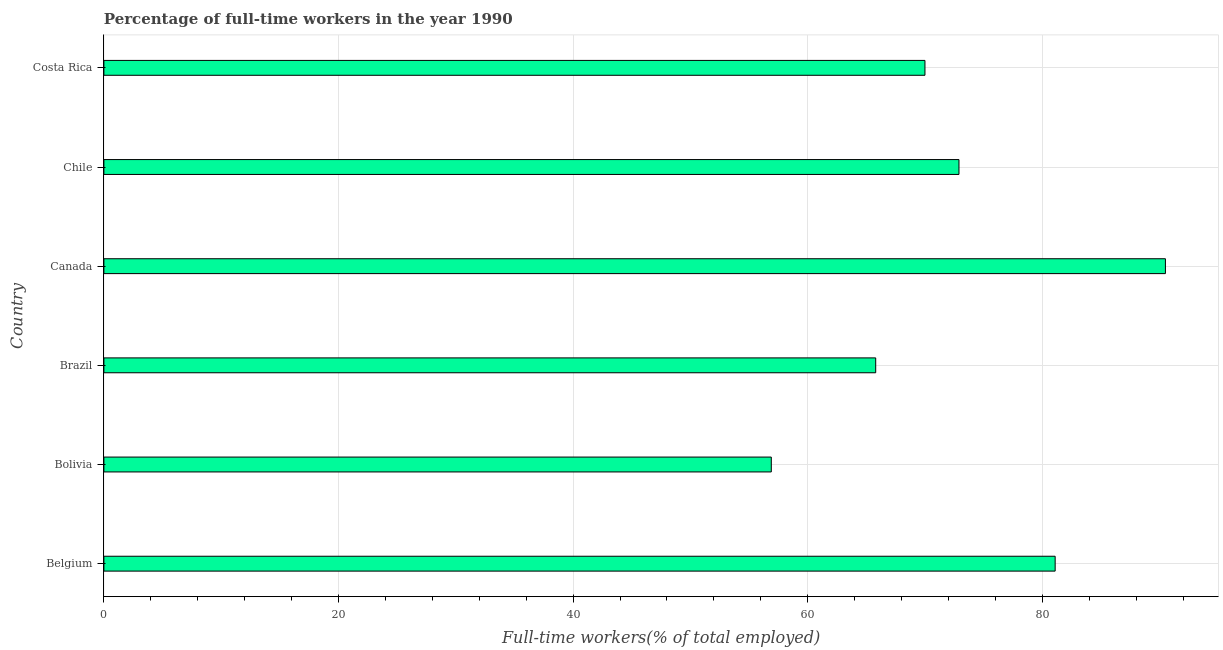Does the graph contain any zero values?
Your answer should be compact. No. Does the graph contain grids?
Provide a short and direct response. Yes. What is the title of the graph?
Ensure brevity in your answer.  Percentage of full-time workers in the year 1990. What is the label or title of the X-axis?
Your response must be concise. Full-time workers(% of total employed). What is the percentage of full-time workers in Costa Rica?
Keep it short and to the point. 70. Across all countries, what is the maximum percentage of full-time workers?
Offer a very short reply. 90.5. Across all countries, what is the minimum percentage of full-time workers?
Offer a terse response. 56.9. In which country was the percentage of full-time workers maximum?
Keep it short and to the point. Canada. In which country was the percentage of full-time workers minimum?
Offer a terse response. Bolivia. What is the sum of the percentage of full-time workers?
Make the answer very short. 437.2. What is the average percentage of full-time workers per country?
Keep it short and to the point. 72.87. What is the median percentage of full-time workers?
Offer a very short reply. 71.45. In how many countries, is the percentage of full-time workers greater than 60 %?
Offer a terse response. 5. What is the ratio of the percentage of full-time workers in Belgium to that in Costa Rica?
Offer a very short reply. 1.16. Is the percentage of full-time workers in Belgium less than that in Brazil?
Your answer should be very brief. No. What is the difference between the highest and the lowest percentage of full-time workers?
Make the answer very short. 33.6. How many bars are there?
Your answer should be very brief. 6. What is the difference between two consecutive major ticks on the X-axis?
Provide a succinct answer. 20. Are the values on the major ticks of X-axis written in scientific E-notation?
Give a very brief answer. No. What is the Full-time workers(% of total employed) of Belgium?
Keep it short and to the point. 81.1. What is the Full-time workers(% of total employed) of Bolivia?
Make the answer very short. 56.9. What is the Full-time workers(% of total employed) in Brazil?
Your response must be concise. 65.8. What is the Full-time workers(% of total employed) in Canada?
Ensure brevity in your answer.  90.5. What is the Full-time workers(% of total employed) in Chile?
Offer a terse response. 72.9. What is the difference between the Full-time workers(% of total employed) in Belgium and Bolivia?
Provide a succinct answer. 24.2. What is the difference between the Full-time workers(% of total employed) in Belgium and Brazil?
Provide a short and direct response. 15.3. What is the difference between the Full-time workers(% of total employed) in Belgium and Canada?
Ensure brevity in your answer.  -9.4. What is the difference between the Full-time workers(% of total employed) in Belgium and Chile?
Your answer should be very brief. 8.2. What is the difference between the Full-time workers(% of total employed) in Belgium and Costa Rica?
Your answer should be very brief. 11.1. What is the difference between the Full-time workers(% of total employed) in Bolivia and Brazil?
Make the answer very short. -8.9. What is the difference between the Full-time workers(% of total employed) in Bolivia and Canada?
Offer a very short reply. -33.6. What is the difference between the Full-time workers(% of total employed) in Bolivia and Chile?
Keep it short and to the point. -16. What is the difference between the Full-time workers(% of total employed) in Brazil and Canada?
Your answer should be compact. -24.7. What is the difference between the Full-time workers(% of total employed) in Brazil and Chile?
Keep it short and to the point. -7.1. What is the difference between the Full-time workers(% of total employed) in Canada and Costa Rica?
Provide a short and direct response. 20.5. What is the ratio of the Full-time workers(% of total employed) in Belgium to that in Bolivia?
Provide a short and direct response. 1.43. What is the ratio of the Full-time workers(% of total employed) in Belgium to that in Brazil?
Provide a succinct answer. 1.23. What is the ratio of the Full-time workers(% of total employed) in Belgium to that in Canada?
Your answer should be compact. 0.9. What is the ratio of the Full-time workers(% of total employed) in Belgium to that in Chile?
Keep it short and to the point. 1.11. What is the ratio of the Full-time workers(% of total employed) in Belgium to that in Costa Rica?
Keep it short and to the point. 1.16. What is the ratio of the Full-time workers(% of total employed) in Bolivia to that in Brazil?
Provide a short and direct response. 0.86. What is the ratio of the Full-time workers(% of total employed) in Bolivia to that in Canada?
Your answer should be very brief. 0.63. What is the ratio of the Full-time workers(% of total employed) in Bolivia to that in Chile?
Provide a succinct answer. 0.78. What is the ratio of the Full-time workers(% of total employed) in Bolivia to that in Costa Rica?
Make the answer very short. 0.81. What is the ratio of the Full-time workers(% of total employed) in Brazil to that in Canada?
Ensure brevity in your answer.  0.73. What is the ratio of the Full-time workers(% of total employed) in Brazil to that in Chile?
Give a very brief answer. 0.9. What is the ratio of the Full-time workers(% of total employed) in Brazil to that in Costa Rica?
Make the answer very short. 0.94. What is the ratio of the Full-time workers(% of total employed) in Canada to that in Chile?
Provide a short and direct response. 1.24. What is the ratio of the Full-time workers(% of total employed) in Canada to that in Costa Rica?
Ensure brevity in your answer.  1.29. What is the ratio of the Full-time workers(% of total employed) in Chile to that in Costa Rica?
Make the answer very short. 1.04. 